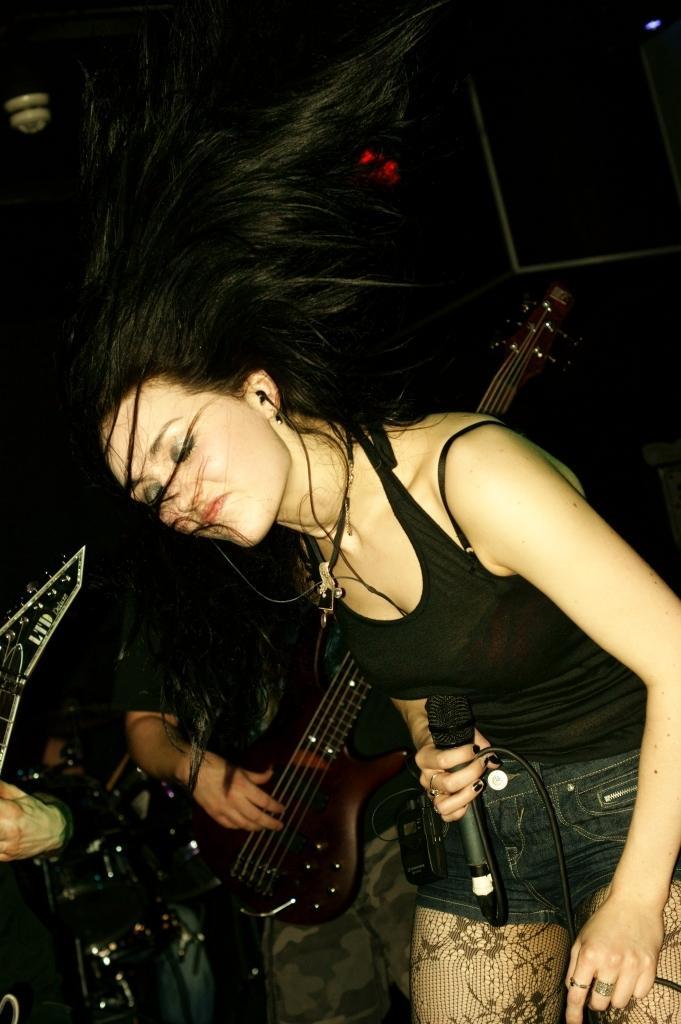In one or two sentences, can you explain what this image depicts? Woman in black t-shirt is holding microphone in her hand. Behind her, we see man in black t-shirt is holding guitar in his hands and playing it. 